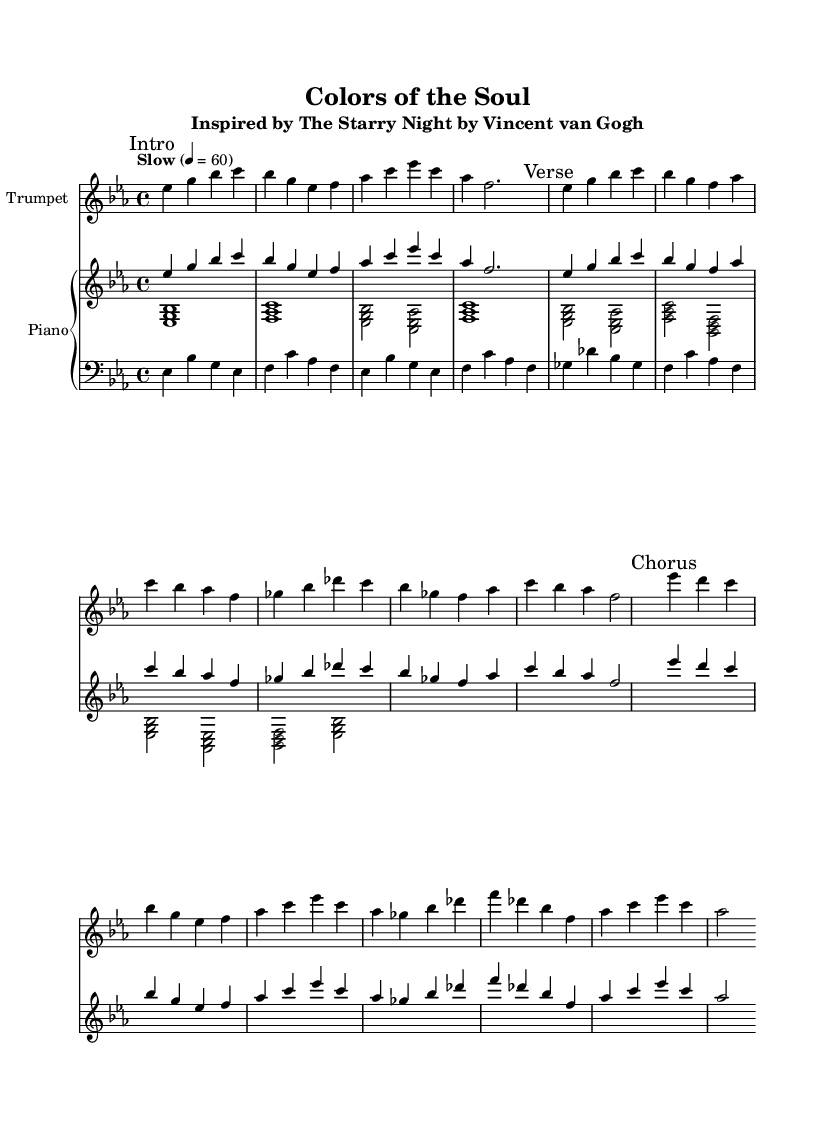What is the key signature of this music? The key signature is B flat major, indicated by the presence of two flat symbols (B flat and E flat) in the key signature.
Answer: B flat major What is the time signature of this music? The time signature is 4/4, which can be identified by the numbers that appear together at the beginning of the score, indicating four beats per measure.
Answer: 4/4 What is the tempo marking of this piece? The tempo marking indicates "Slow" with a metronome setting of 60 beats per minute, which is clearly stated in the score at the beginning.
Answer: Slow 4 = 60 How many measures are in the introduction? By counting the measures in the "Intro" section marked in the score, we find there are four measures in total before transitioning to the verse section.
Answer: 4 What is the highest note in the trumpet section? The highest note in the trumpet section is C, which is found in the "Verse" segment as well as in the "Chorus."
Answer: C What type of jazz influence is present in this music? The piece exemplifies a soulful jazz influence, characterized by the emotional expressiveness and rhythmic qualities typical of the genre, especially evident in the ballad form.
Answer: Soulful jazz Which visual artwork inspired this composition? The composition is inspired by "The Starry Night" by Vincent van Gogh, as stated in the subtitle of the sheet music.
Answer: The Starry Night 